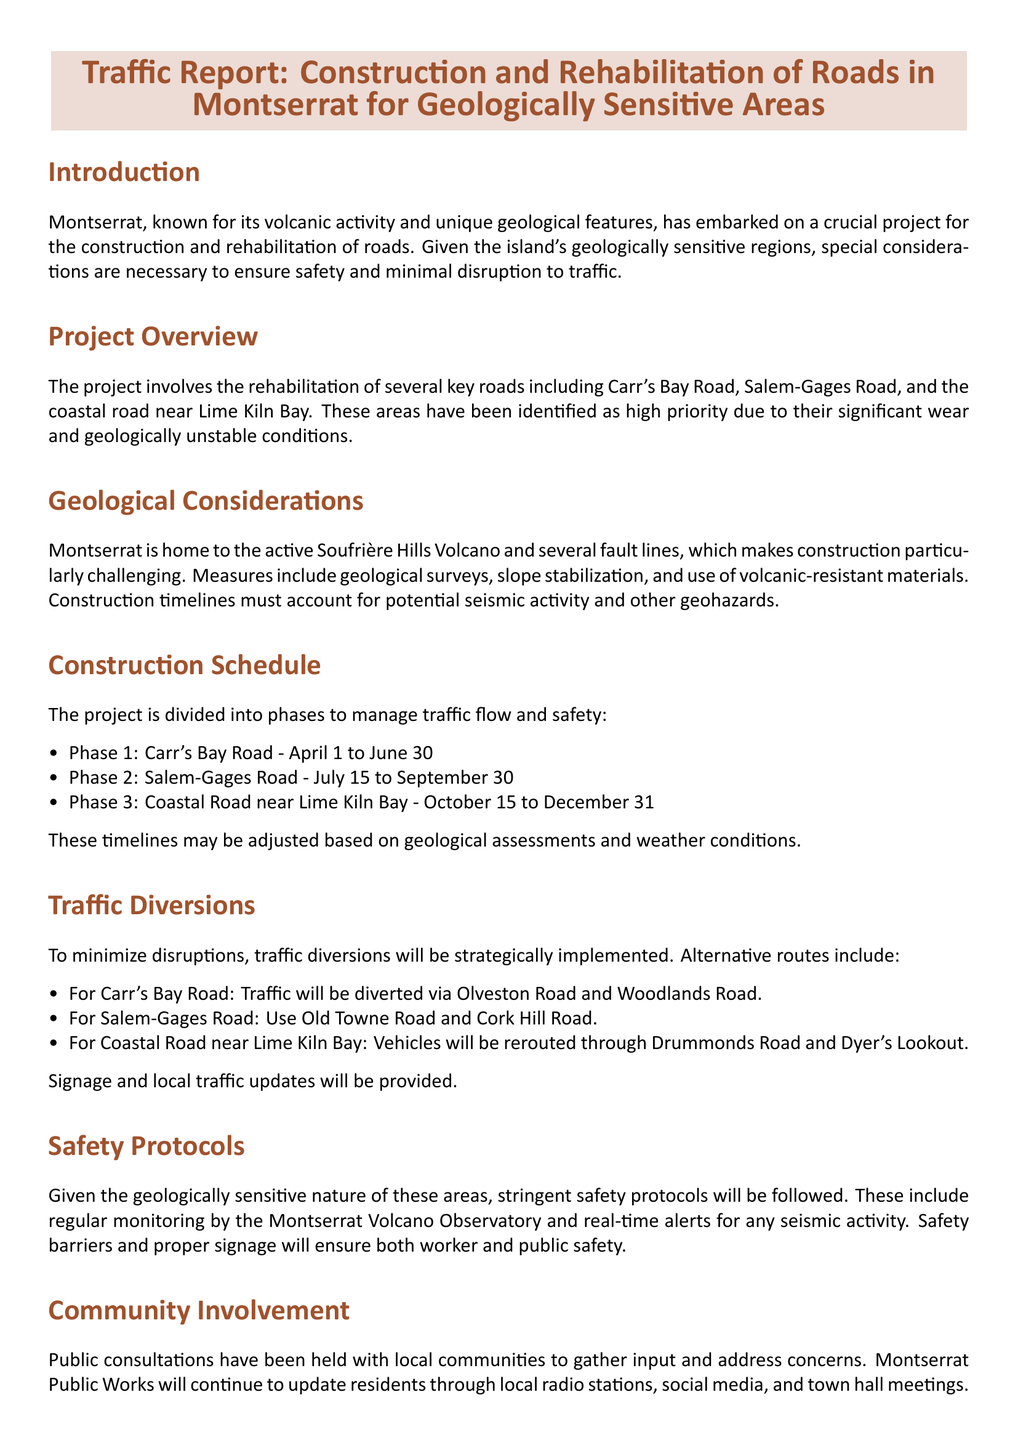what is the title of the document? The title of the document is displayed at the top of the report and indicates its focus on traffic related to road construction in geologically sensitive areas of Montserrat.
Answer: Traffic Report: Construction and Rehabilitation of Roads in Montserrat for Geologically Sensitive Areas what is the first phase of the construction schedule? The first phase is detailed in the construction schedule, listing Carr's Bay Road as the initial focus of the work.
Answer: Carr's Bay Road when does Phase 2 start? The start date for Phase 2 is clearly stated in the construction schedule within the document.
Answer: July 15 what are the alternative routes for Carr's Bay Road? The alternative routes provided in the document help to inform the public about detours around construction activities on Carr's Bay Road.
Answer: Olveston Road and Woodlands Road what safety protocols are mentioned in the report? The report outlines specific safety protocols that must be followed, particularly given the geological context of the project.
Answer: Regular monitoring by the Montserrat Volcano Observatory why are traffic diversions necessary during the construction? The need for traffic diversions is explained in the context of minimizing disruptions due to construction activities.
Answer: To minimize disruptions how will the community be involved throughout the project? The document highlights the engagement of local communities and how public consultations are conducted to gather input.
Answer: Public consultations what is the completion date for the Coastal Road project? The completion date for the Coastal Road work is established within the timeline section of the document.
Answer: December 31 